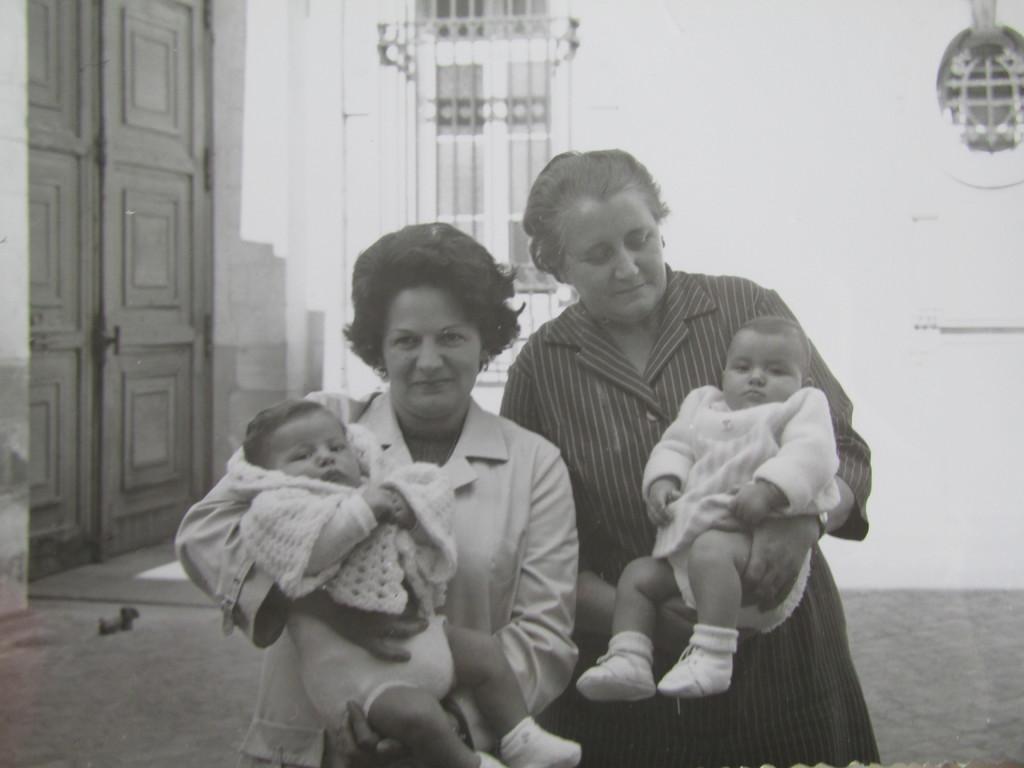Can you describe this image briefly? In this image I can see two persons are holding babies. In the background I can see the door and the window to the wall. 